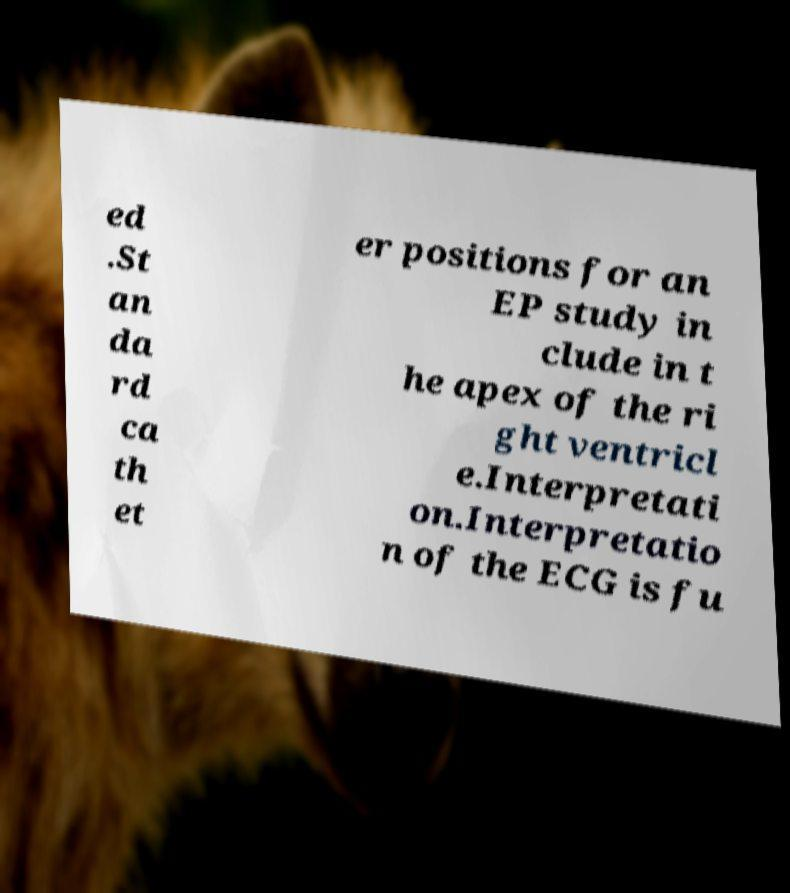Could you assist in decoding the text presented in this image and type it out clearly? ed .St an da rd ca th et er positions for an EP study in clude in t he apex of the ri ght ventricl e.Interpretati on.Interpretatio n of the ECG is fu 